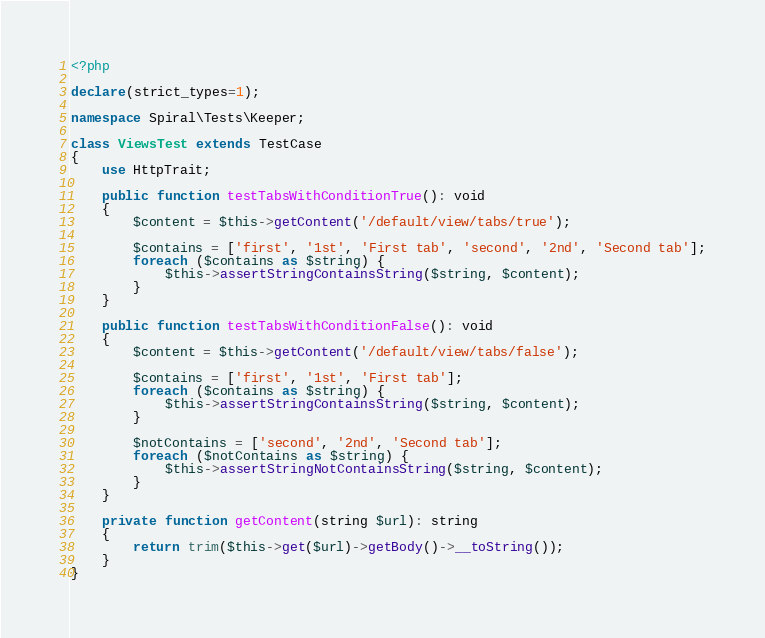Convert code to text. <code><loc_0><loc_0><loc_500><loc_500><_PHP_><?php

declare(strict_types=1);

namespace Spiral\Tests\Keeper;

class ViewsTest extends TestCase
{
    use HttpTrait;

    public function testTabsWithConditionTrue(): void
    {
        $content = $this->getContent('/default/view/tabs/true');

        $contains = ['first', '1st', 'First tab', 'second', '2nd', 'Second tab'];
        foreach ($contains as $string) {
            $this->assertStringContainsString($string, $content);
        }
    }

    public function testTabsWithConditionFalse(): void
    {
        $content = $this->getContent('/default/view/tabs/false');

        $contains = ['first', '1st', 'First tab'];
        foreach ($contains as $string) {
            $this->assertStringContainsString($string, $content);
        }

        $notContains = ['second', '2nd', 'Second tab'];
        foreach ($notContains as $string) {
            $this->assertStringNotContainsString($string, $content);
        }
    }

    private function getContent(string $url): string
    {
        return trim($this->get($url)->getBody()->__toString());
    }
}
</code> 